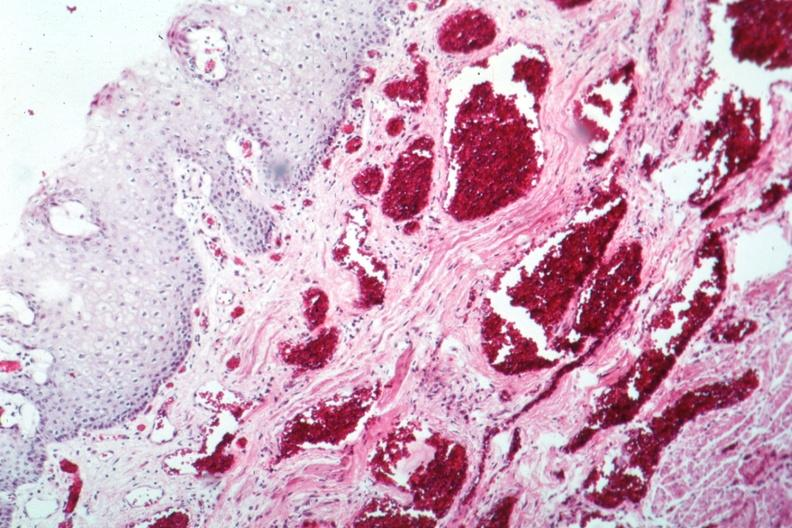does this partially fixed gross show about as good as your can get?
Answer the question using a single word or phrase. No 